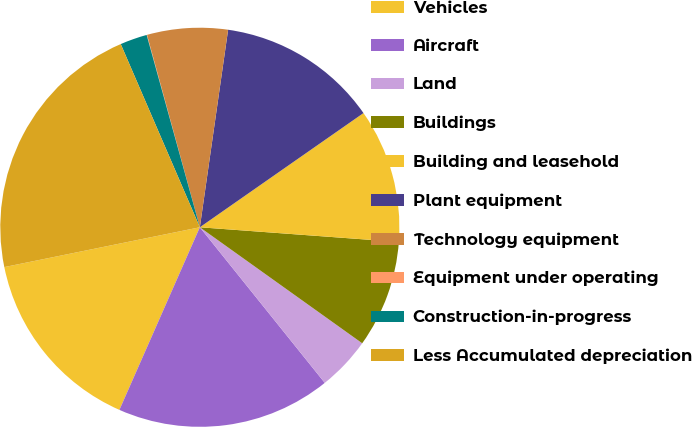Convert chart to OTSL. <chart><loc_0><loc_0><loc_500><loc_500><pie_chart><fcel>Vehicles<fcel>Aircraft<fcel>Land<fcel>Buildings<fcel>Building and leasehold<fcel>Plant equipment<fcel>Technology equipment<fcel>Equipment under operating<fcel>Construction-in-progress<fcel>Less Accumulated depreciation<nl><fcel>15.2%<fcel>17.37%<fcel>4.36%<fcel>8.7%<fcel>10.87%<fcel>13.04%<fcel>6.53%<fcel>0.03%<fcel>2.19%<fcel>21.71%<nl></chart> 